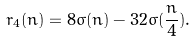Convert formula to latex. <formula><loc_0><loc_0><loc_500><loc_500>r _ { 4 } ( n ) = 8 \sigma ( n ) - 3 2 \sigma ( \frac { n } { 4 } ) .</formula> 